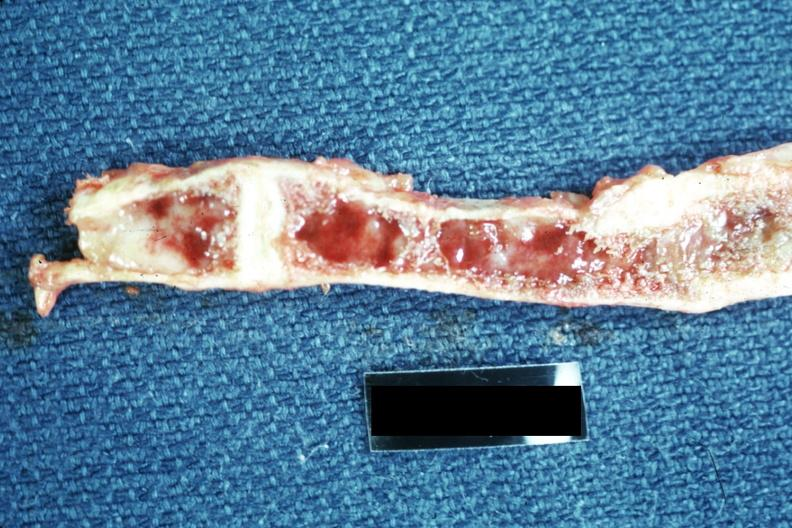s joints present?
Answer the question using a single word or phrase. Yes 